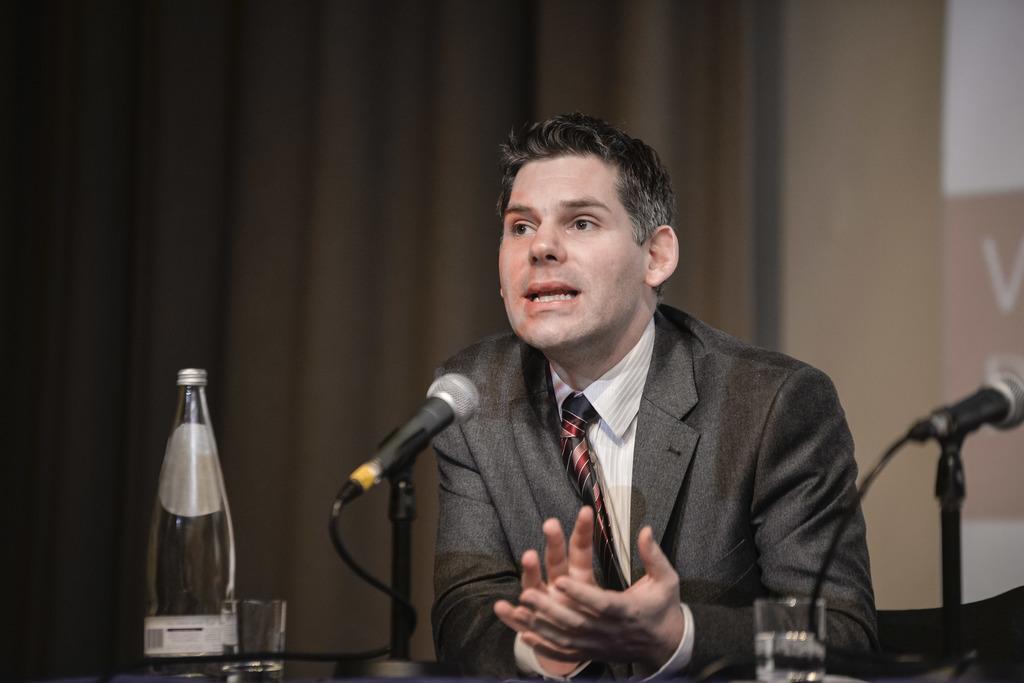Describe this image in one or two sentences. In the picture we can see a man near the desk and talking in the microphone which is on the desk and besides it, we can see a bottle and glass on the table, in the background we can see a wall with a curtain. 